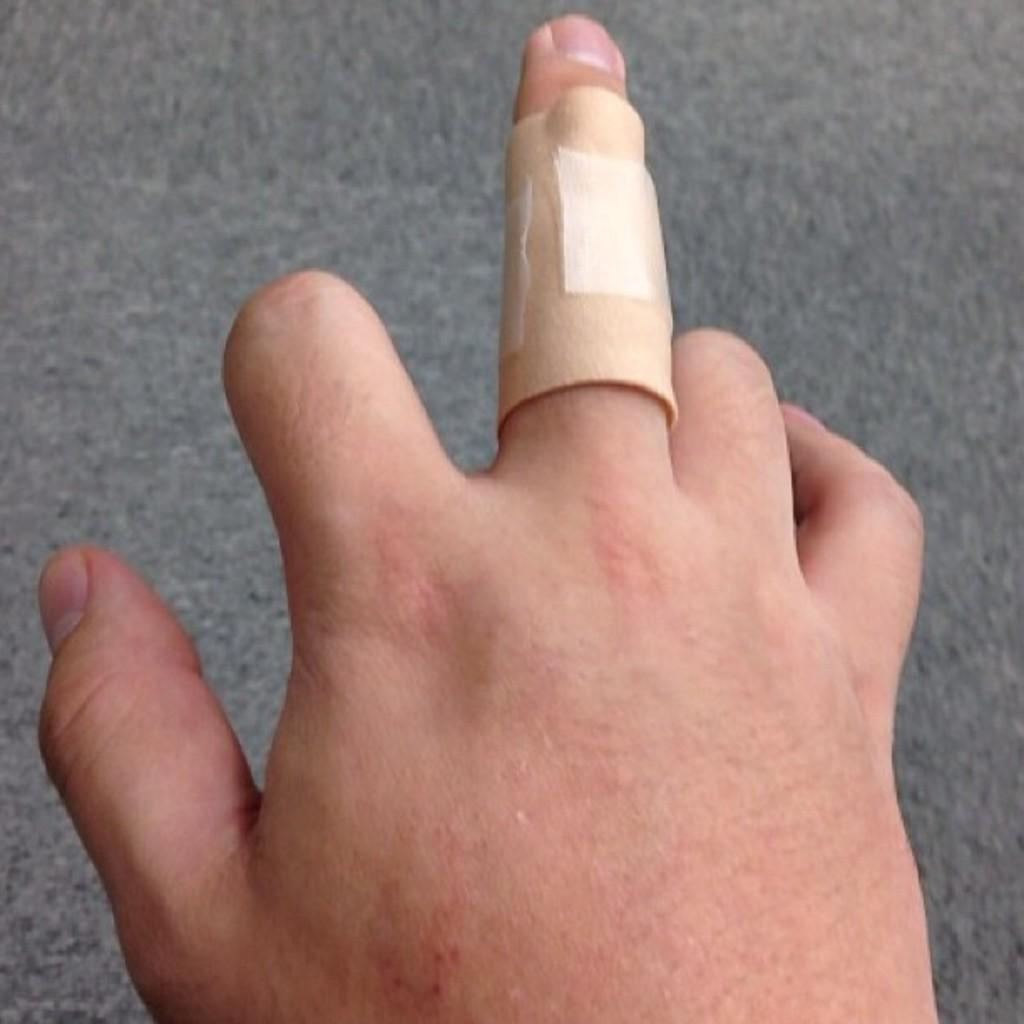What is the main subject of the image? There is a person in the image. Can you describe any specific detail about the person? The person has a band aid tied to their middle finger. What type of event is taking place in the image involving a robin and a railway? There is no event, robin, or railway present in the image. The image only features a person with a band aid on their middle finger. 